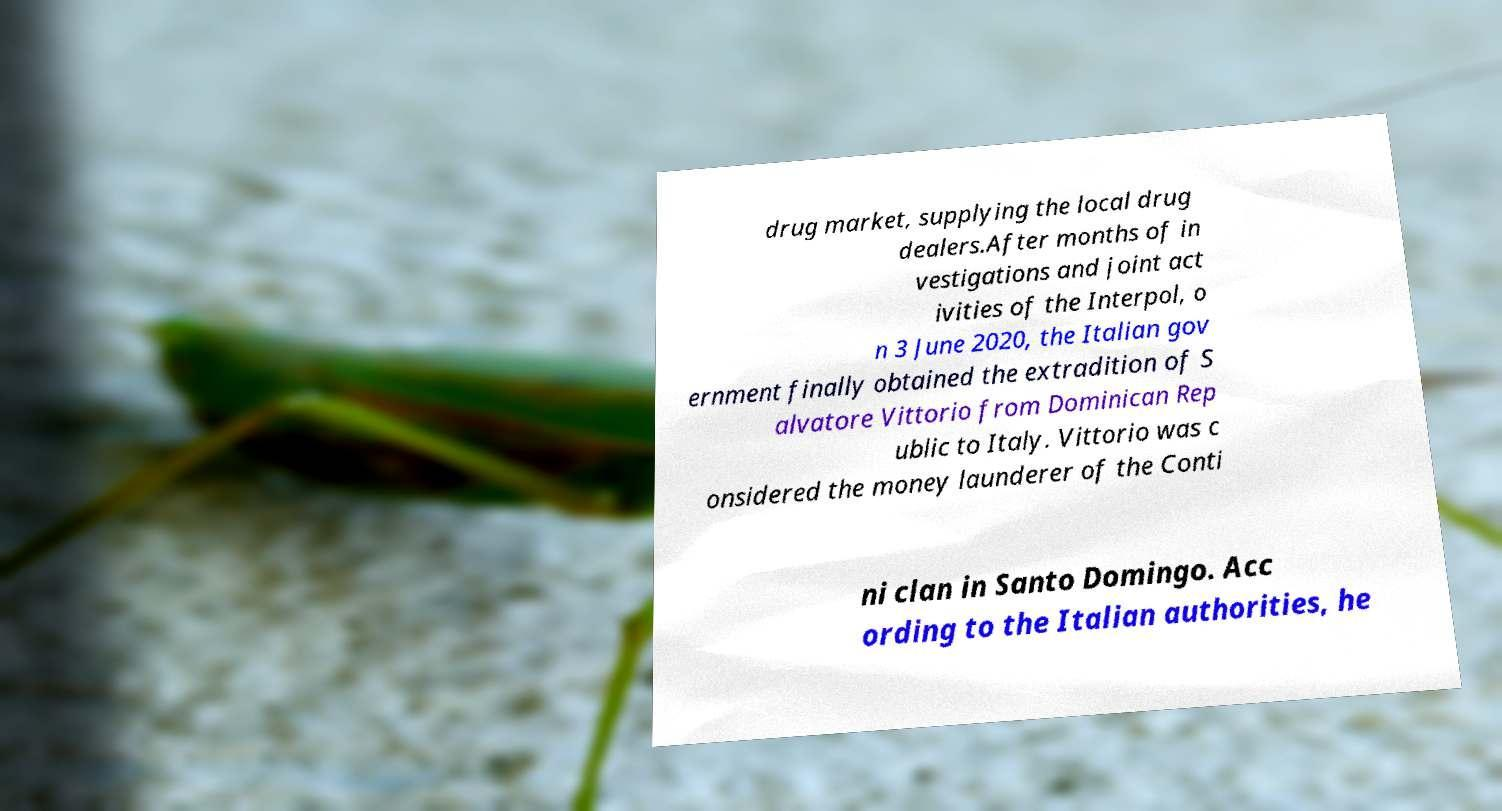Please identify and transcribe the text found in this image. drug market, supplying the local drug dealers.After months of in vestigations and joint act ivities of the Interpol, o n 3 June 2020, the Italian gov ernment finally obtained the extradition of S alvatore Vittorio from Dominican Rep ublic to Italy. Vittorio was c onsidered the money launderer of the Conti ni clan in Santo Domingo. Acc ording to the Italian authorities, he 